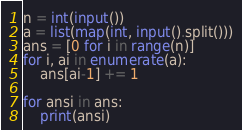Convert code to text. <code><loc_0><loc_0><loc_500><loc_500><_Python_>n = int(input())
a = list(map(int, input().split()))
ans = [0 for i in range(n)]
for i, ai in enumerate(a):
    ans[ai-1] += 1

for ansi in ans:
    print(ansi)

</code> 